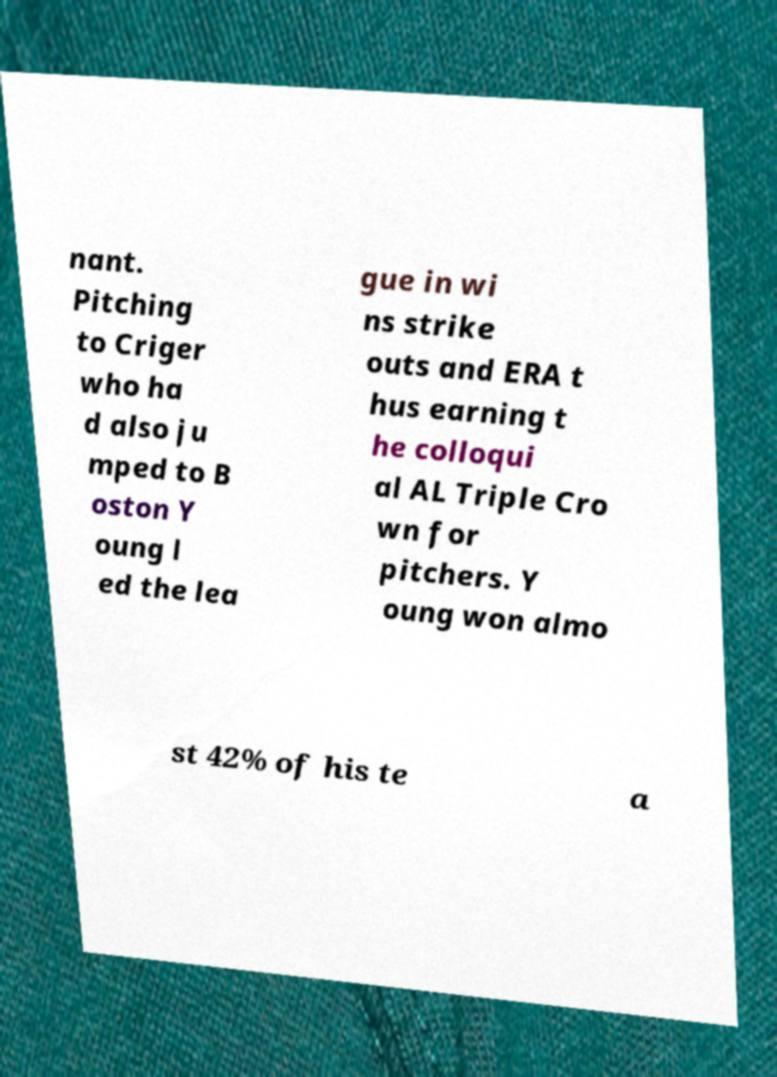Could you extract and type out the text from this image? nant. Pitching to Criger who ha d also ju mped to B oston Y oung l ed the lea gue in wi ns strike outs and ERA t hus earning t he colloqui al AL Triple Cro wn for pitchers. Y oung won almo st 42% of his te a 